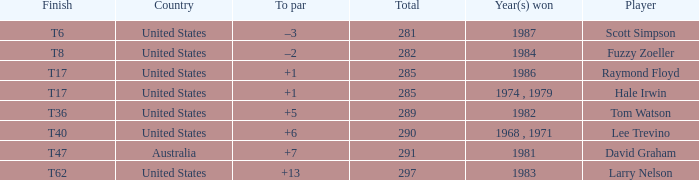What is the year that Hale Irwin won with 285 points? 1974 , 1979. 